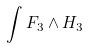<formula> <loc_0><loc_0><loc_500><loc_500>\int F _ { 3 } \wedge H _ { 3 }</formula> 